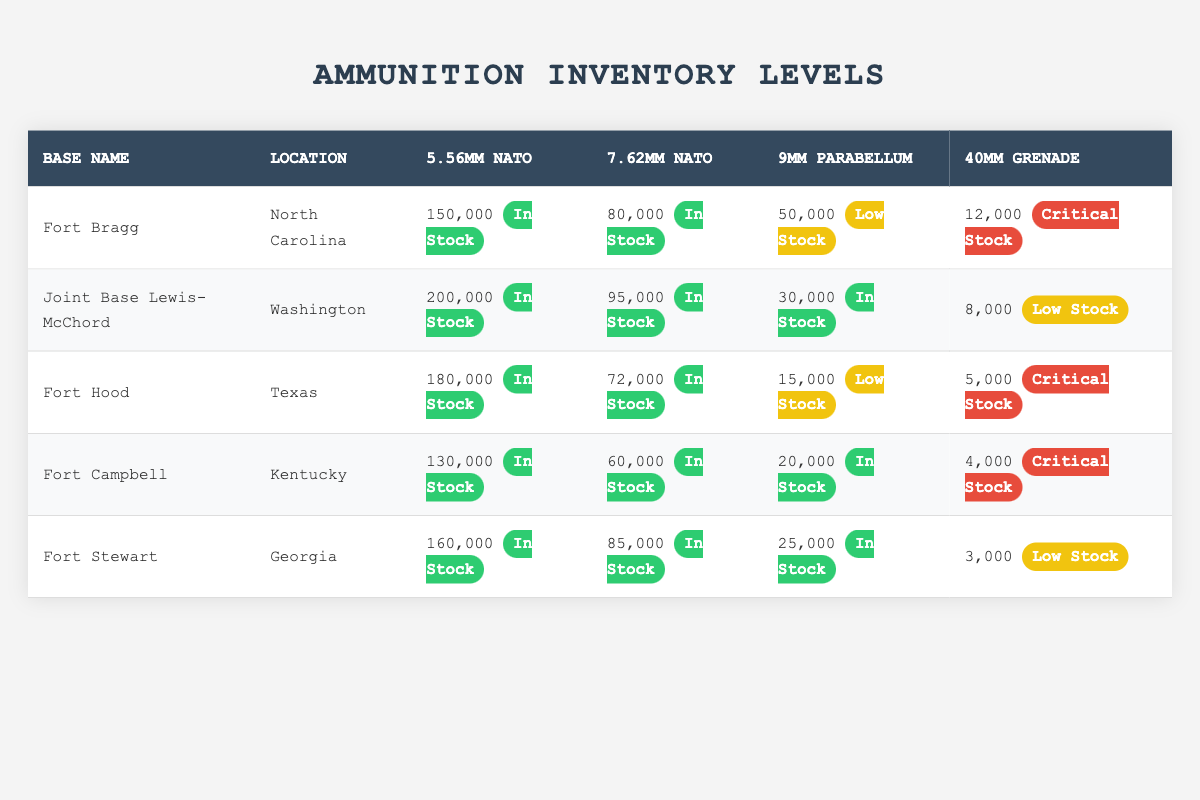What is the total quantity of 5.56mm NATO ammunition across all bases? To find the total quantity, we need to add the quantities of 5.56mm NATO from all bases: 150,000 (Fort Bragg) + 200,000 (Joint Base Lewis-McChord) + 180,000 (Fort Hood) + 130,000 (Fort Campbell) + 160,000 (Fort Stewart) = 920,000.
Answer: 920,000 Which base has the lowest quantity of 40mm Grenade ammunition? Reviewing the 40mm Grenade ammunition quantities, we see that Fort Stewart has 3,000, Fort Campbell has 4,000, Fort Hood has 5,000, Joint Base Lewis-McChord has 8,000, and Fort Bragg has 12,000. The base with the lowest amount is Fort Stewart.
Answer: Fort Stewart Is the 9mm Parabellum ammunition status at Fort Campbell "In Stock"? Checking the status of 9mm Parabellum at Fort Campbell, it is listed as "In Stock".
Answer: Yes What percentage of 7.62mm NATO ammunition at Joint Base Lewis-McChord is compared to Fort Bragg? The quantity of 7.62mm NATO at Joint Base Lewis-McChord is 95,000, while at Fort Bragg it is 80,000. To find the percentage, we calculate (95,000 / 80,000) * 100 = 118.75%. Thus, Joint Base Lewis-McChord has 118.75% of the quantity of Fort Bragg.
Answer: 118.75% Which base has the highest quantity of 9mm Parabellum ammunition? By comparing the quantities of 9mm Parabellum for each base: Fort Bragg has 50,000, Joint Base Lewis-McChord has 30,000, Fort Hood has 15,000, Fort Campbell has 20,000, and Fort Stewart has 25,000. The highest quantity is at Fort Bragg with 50,000.
Answer: Fort Bragg How many bases have "Low Stock" status for 40mm Grenade? Analyzing the status for 40mm Grenade: Fort Hood and Fort Campbell have "Critical Stock" status, Fort Bragg has "Critical Stock," and Joint Base Lewis-McChord has "Low Stock." Only Fort Stewart shows "Low Stock." Thus, only 1 base has "Low Stock."
Answer: 1 What is the average quantity of all types of ammunition at Fort Hood? To calculate the average at Fort Hood: add all ammunition quantities: 180,000 (5.56mm) + 72,000 (7.62mm) + 15,000 (9mm) + 5,000 (40mm) = 272,000. There are 4 types of ammunition, so the average is 272,000 / 4 = 68,000.
Answer: 68,000 Is the 5.56mm NATO ammunition status at Fort Stewart "In Stock"? Reviewing the status at Fort Stewart for 5.56mm NATO, it is confirmed as "In Stock."
Answer: Yes 